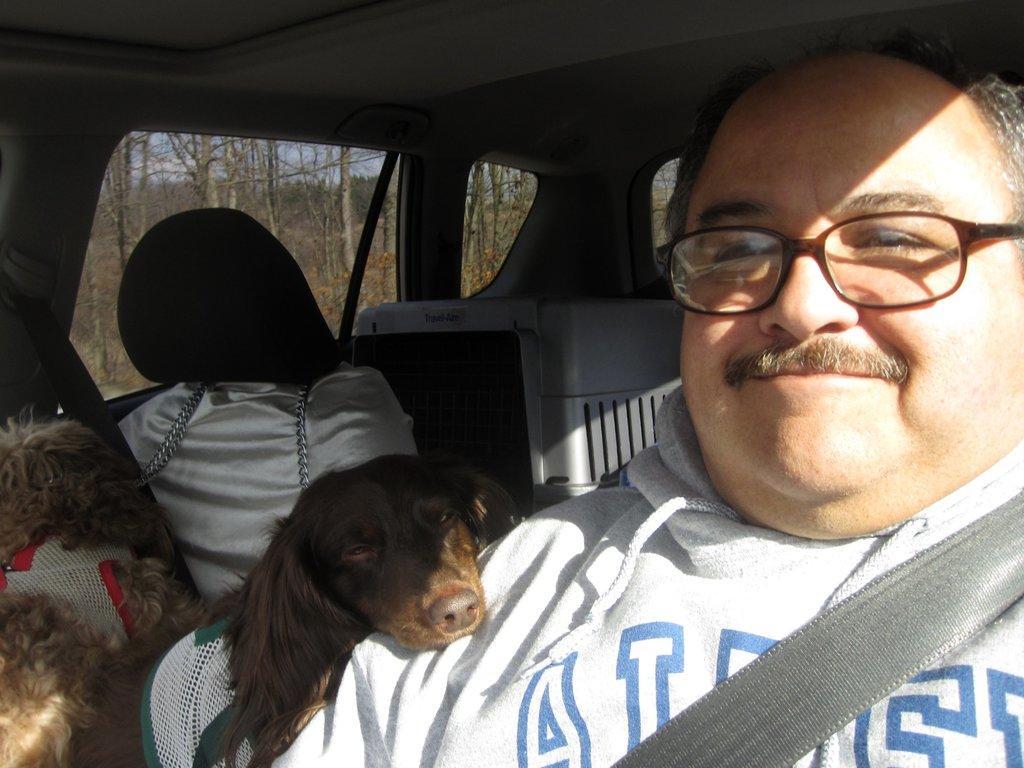Could you give a brief overview of what you see in this image? Inside picture of a vehicle. This man is sitting and wore spectacles. Beside this man there is a dog. Backside of this man there is a air cooler. Outside of this window there are bare trees. 